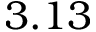Convert formula to latex. <formula><loc_0><loc_0><loc_500><loc_500>3 . 1 3</formula> 